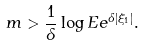Convert formula to latex. <formula><loc_0><loc_0><loc_500><loc_500>m > \frac { 1 } { \delta } \log E e ^ { \delta | \xi _ { 1 } | } .</formula> 